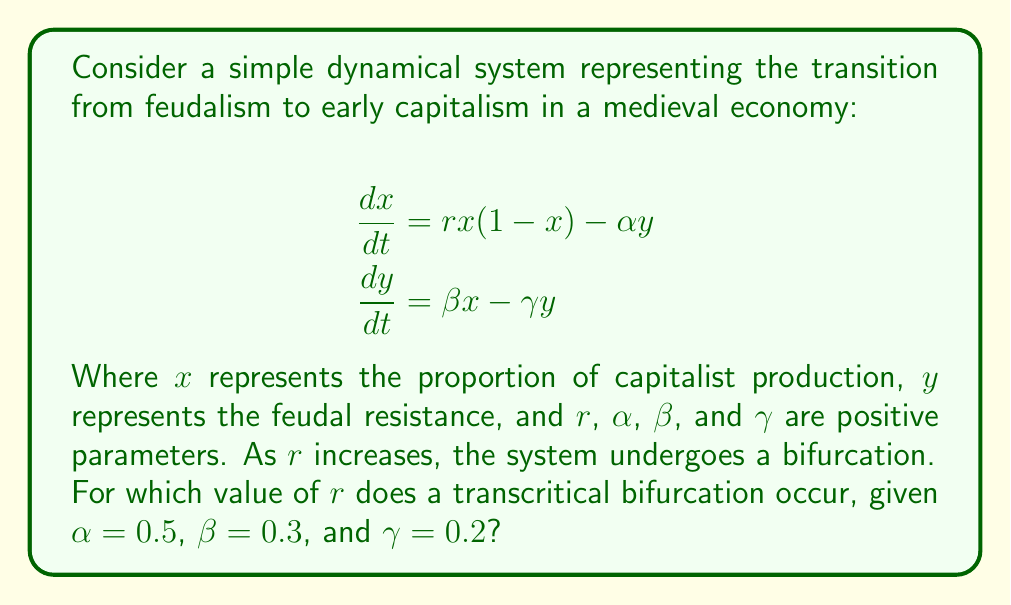Teach me how to tackle this problem. To find the transcritical bifurcation point, we need to follow these steps:

1) First, find the equilibrium points of the system by setting both equations to zero:

   $$rx(1-x) - \alpha y = 0$$
   $$\beta x - \gamma y = 0$$

2) From the second equation, we can express $y$ in terms of $x$:

   $$y = \frac{\beta x}{\gamma}$$

3) Substitute this into the first equation:

   $$rx(1-x) - \alpha \frac{\beta x}{\gamma} = 0$$

4) Factor out $x$:

   $$x(r(1-x) - \frac{\alpha \beta}{\gamma}) = 0$$

5) This equation is satisfied when $x = 0$ or when the term in parentheses is zero. The transcritical bifurcation occurs when these two solutions intersect, i.e., when:

   $$r(1-0) - \frac{\alpha \beta}{\gamma} = 0$$

6) Solve for $r$:

   $$r = \frac{\alpha \beta}{\gamma}$$

7) Substitute the given values:

   $$r = \frac{0.5 \cdot 0.3}{0.2} = 0.75$$

Therefore, the transcritical bifurcation occurs when $r = 0.75$.
Answer: $r = 0.75$ 